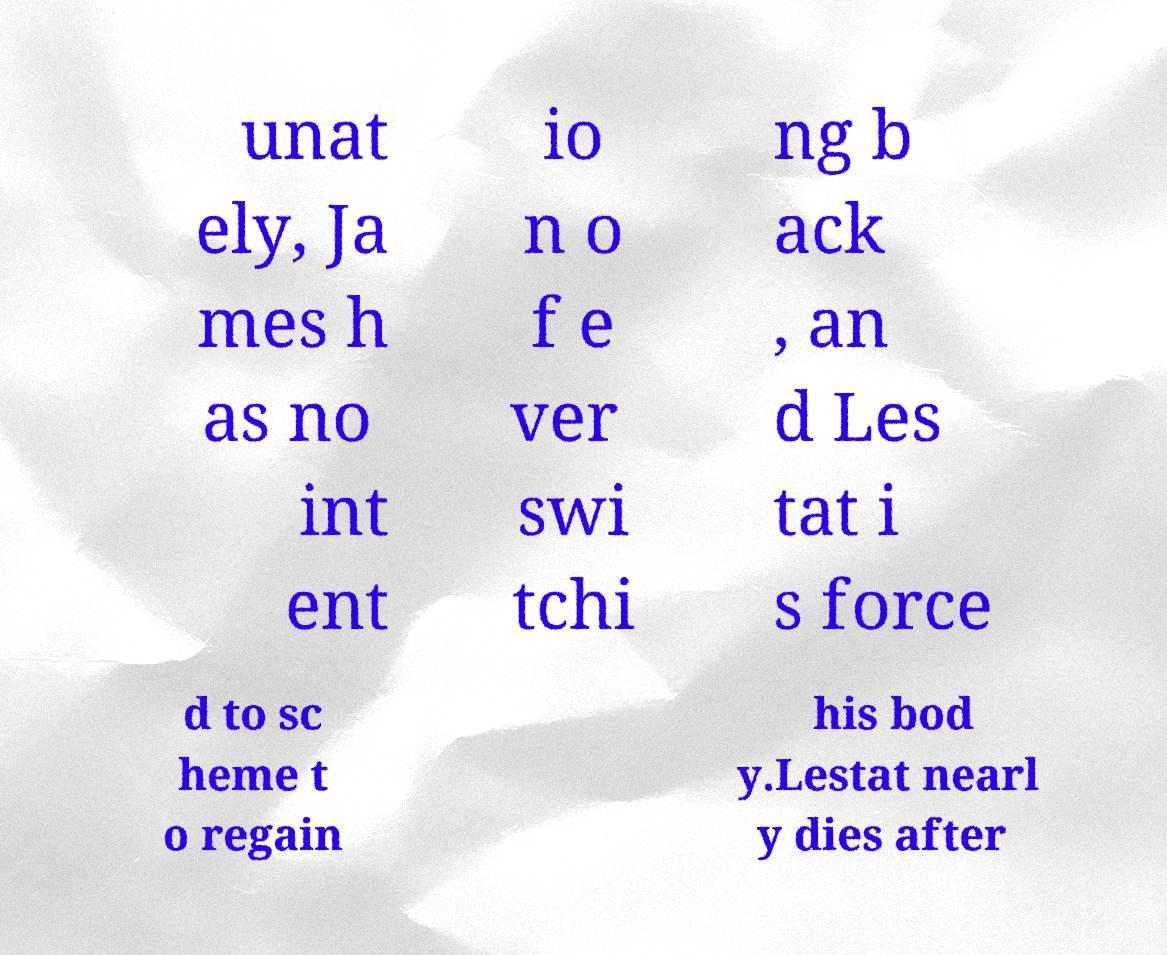Can you read and provide the text displayed in the image?This photo seems to have some interesting text. Can you extract and type it out for me? unat ely, Ja mes h as no int ent io n o f e ver swi tchi ng b ack , an d Les tat i s force d to sc heme t o regain his bod y.Lestat nearl y dies after 